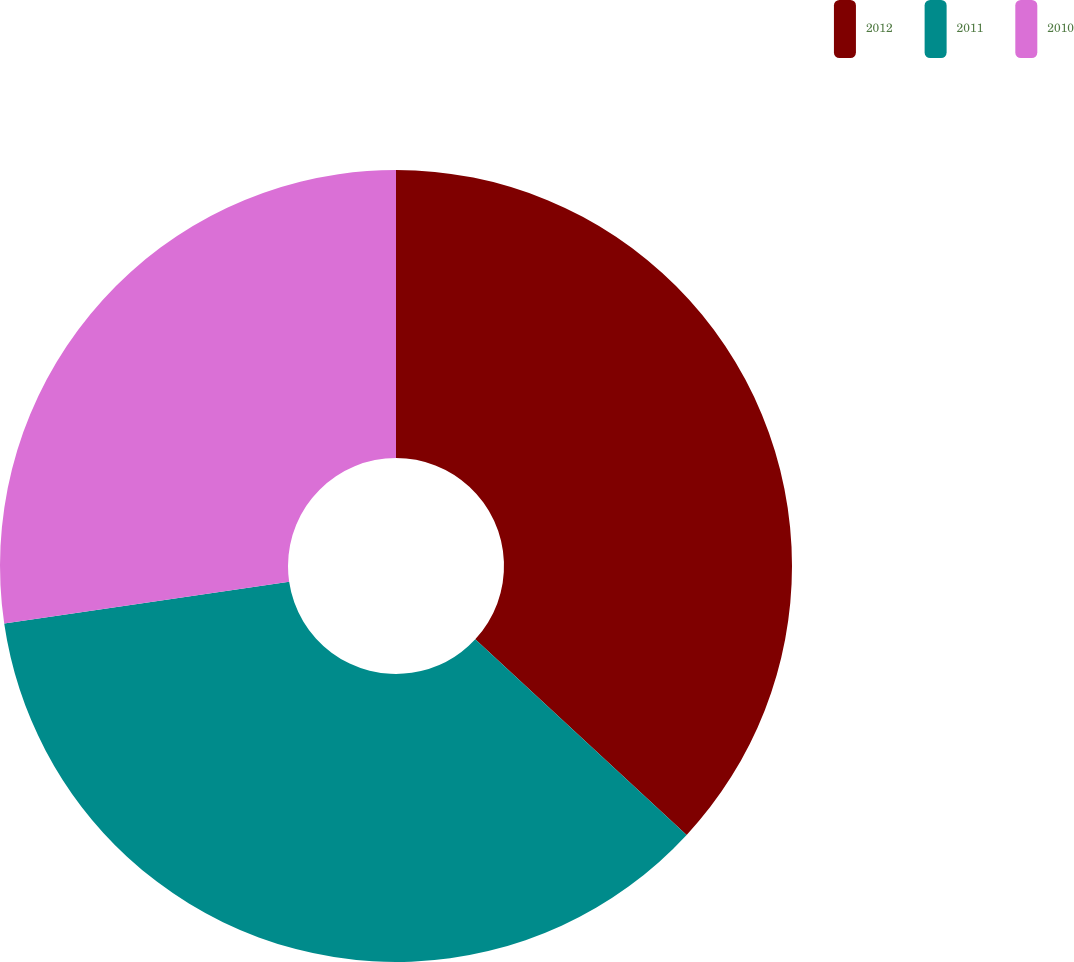Convert chart to OTSL. <chart><loc_0><loc_0><loc_500><loc_500><pie_chart><fcel>2012<fcel>2011<fcel>2010<nl><fcel>36.88%<fcel>35.79%<fcel>27.32%<nl></chart> 